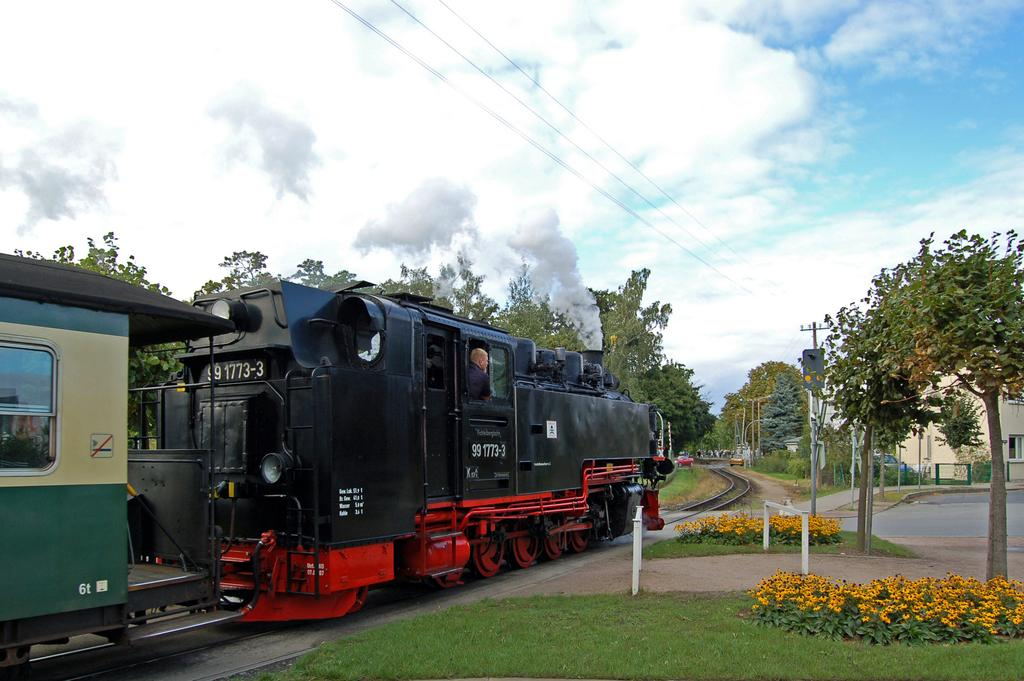What is the main subject of the image? The main subject of the image is a train on the track. What can be seen in the background of the image? There are trees, a building, poles and wires, and the sky visible in the image. What type of vegetation is present at the bottom of the image? There is grass and flowers at the bottom of the image. How many boys are riding the dinosaurs in the image? There are no boys or dinosaurs present in the image. What type of polish is being applied to the train in the image? There is no polish or application process visible in the image; it simply shows a train on the track. 